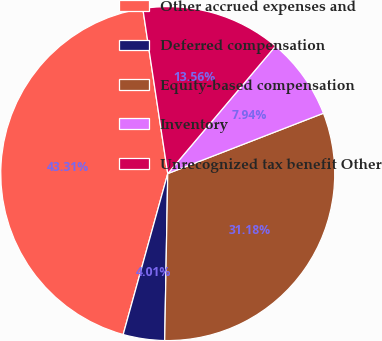Convert chart. <chart><loc_0><loc_0><loc_500><loc_500><pie_chart><fcel>Other accrued expenses and<fcel>Deferred compensation<fcel>Equity-based compensation<fcel>Inventory<fcel>Unrecognized tax benefit Other<nl><fcel>43.31%<fcel>4.01%<fcel>31.18%<fcel>7.94%<fcel>13.56%<nl></chart> 